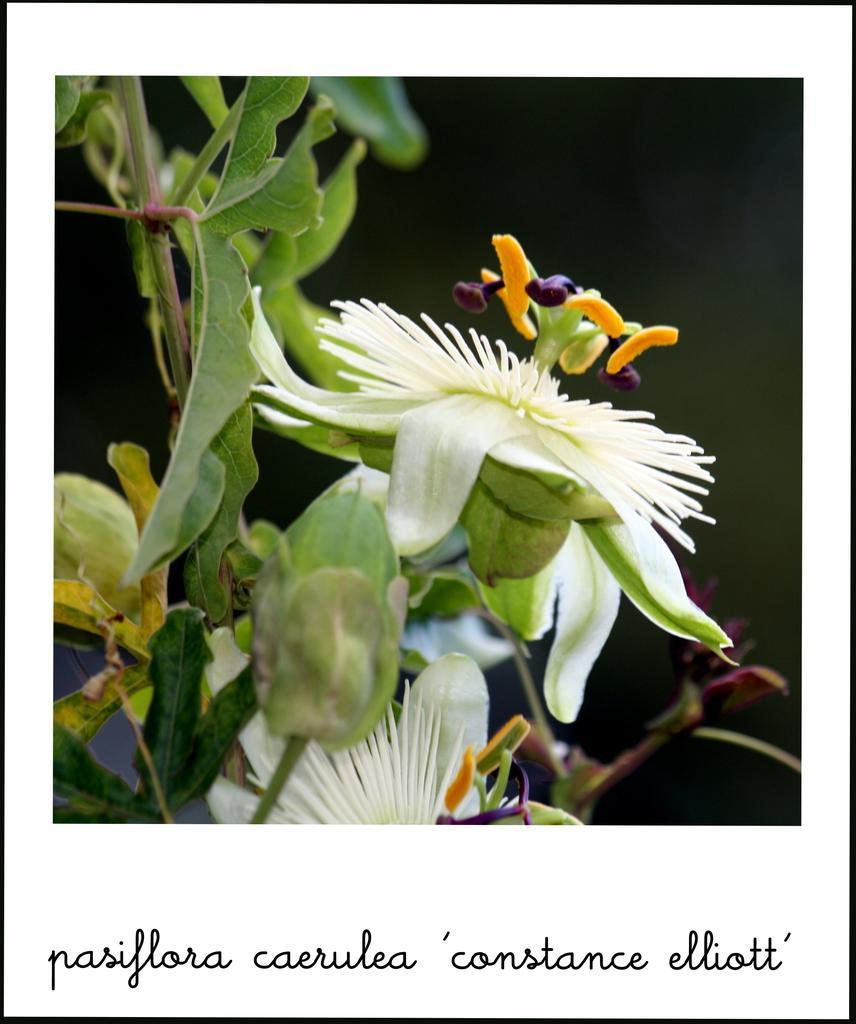Could you give a brief overview of what you see in this image? In this image we can see a poster. In the poster we can see flowers to the plants. Behind the plants the image is blurred. At the bottom we can see the text. 